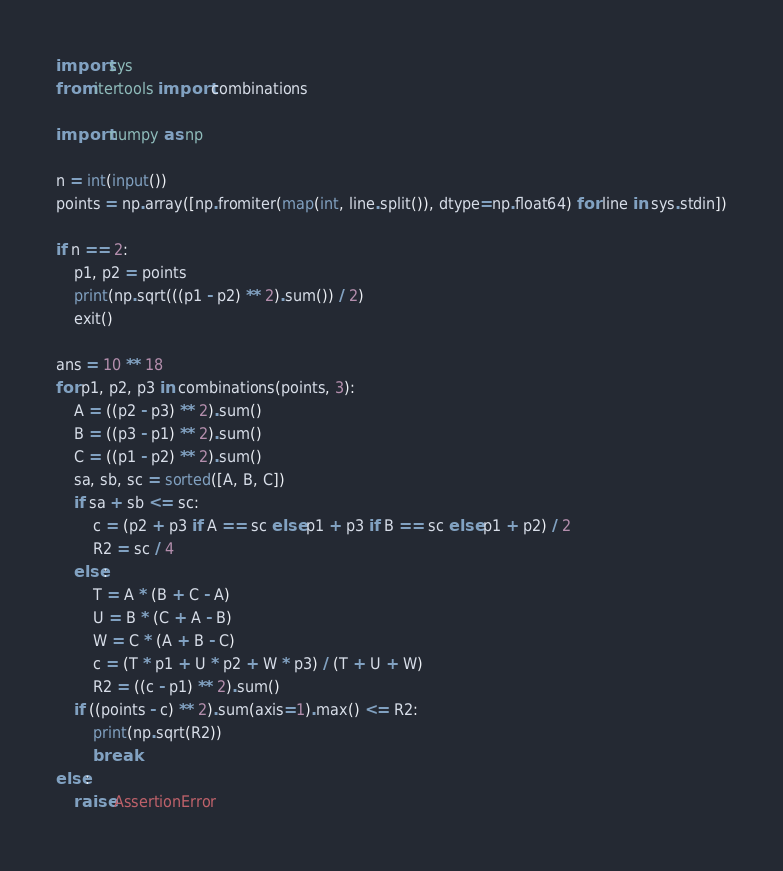Convert code to text. <code><loc_0><loc_0><loc_500><loc_500><_Python_>import sys
from itertools import combinations

import numpy as np

n = int(input())
points = np.array([np.fromiter(map(int, line.split()), dtype=np.float64) for line in sys.stdin])

if n == 2:
    p1, p2 = points
    print(np.sqrt(((p1 - p2) ** 2).sum()) / 2)
    exit()

ans = 10 ** 18
for p1, p2, p3 in combinations(points, 3):
    A = ((p2 - p3) ** 2).sum()
    B = ((p3 - p1) ** 2).sum()
    C = ((p1 - p2) ** 2).sum()
    sa, sb, sc = sorted([A, B, C])
    if sa + sb <= sc:
        c = (p2 + p3 if A == sc else p1 + p3 if B == sc else p1 + p2) / 2
        R2 = sc / 4
    else:
        T = A * (B + C - A)
        U = B * (C + A - B)
        W = C * (A + B - C)
        c = (T * p1 + U * p2 + W * p3) / (T + U + W)
        R2 = ((c - p1) ** 2).sum()
    if ((points - c) ** 2).sum(axis=1).max() <= R2:
        print(np.sqrt(R2))
        break
else:
    raise AssertionError
</code> 